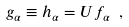<formula> <loc_0><loc_0><loc_500><loc_500>g _ { \alpha } \equiv h _ { \alpha } = U f _ { \alpha } \ ,</formula> 